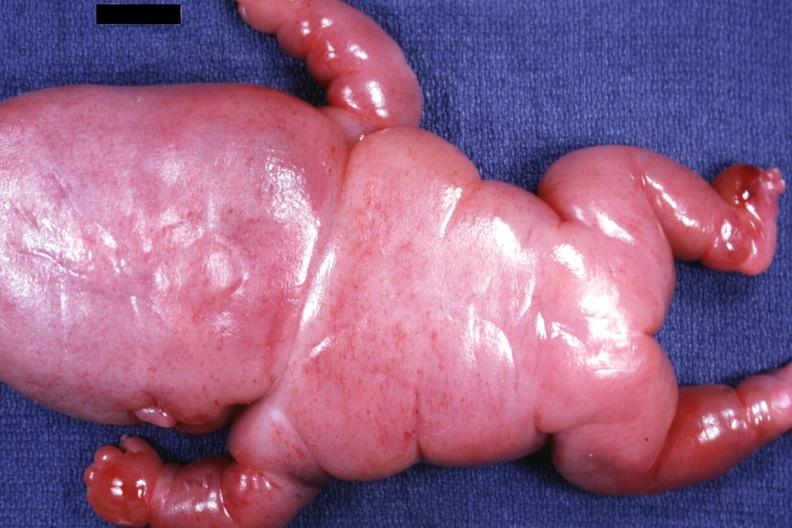what does this image show?
Answer the question using a single word or phrase. Posterior view of body slide 